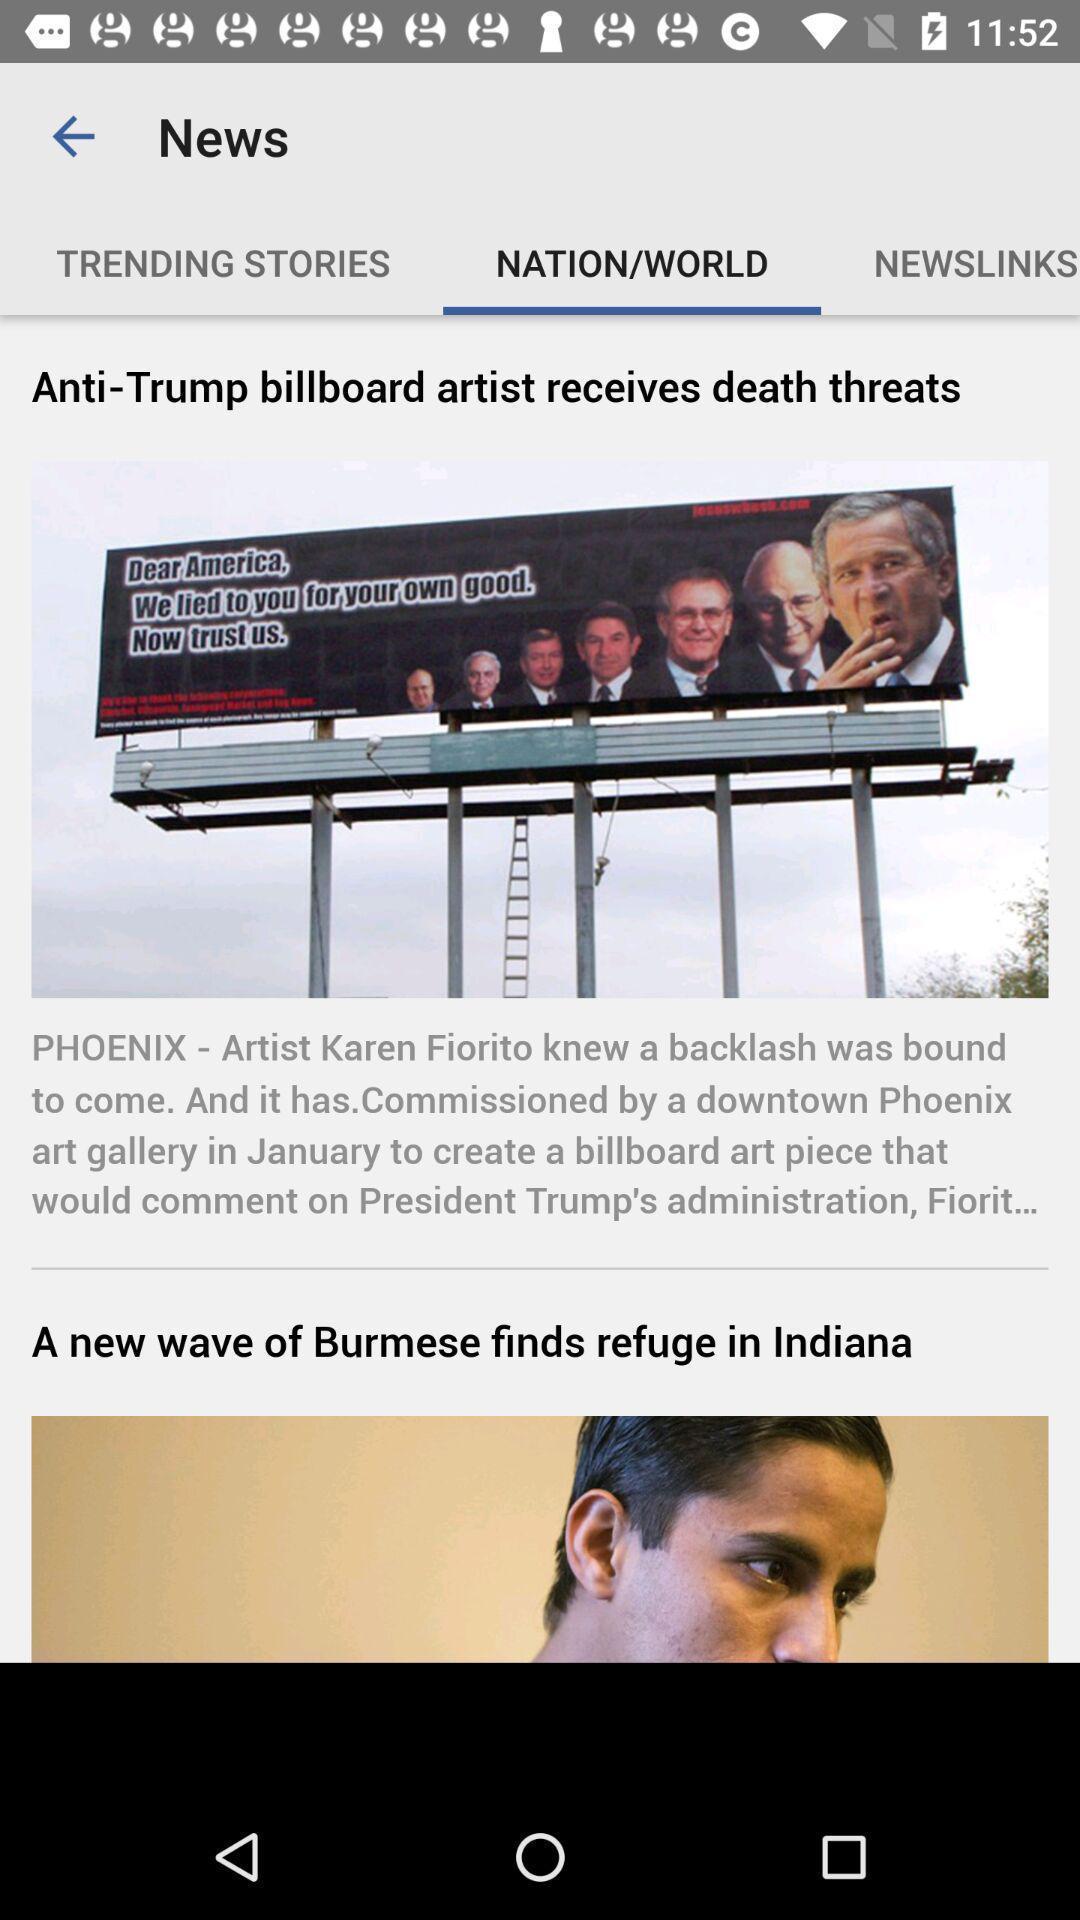What can you discern from this picture? Page showing breaking news. 